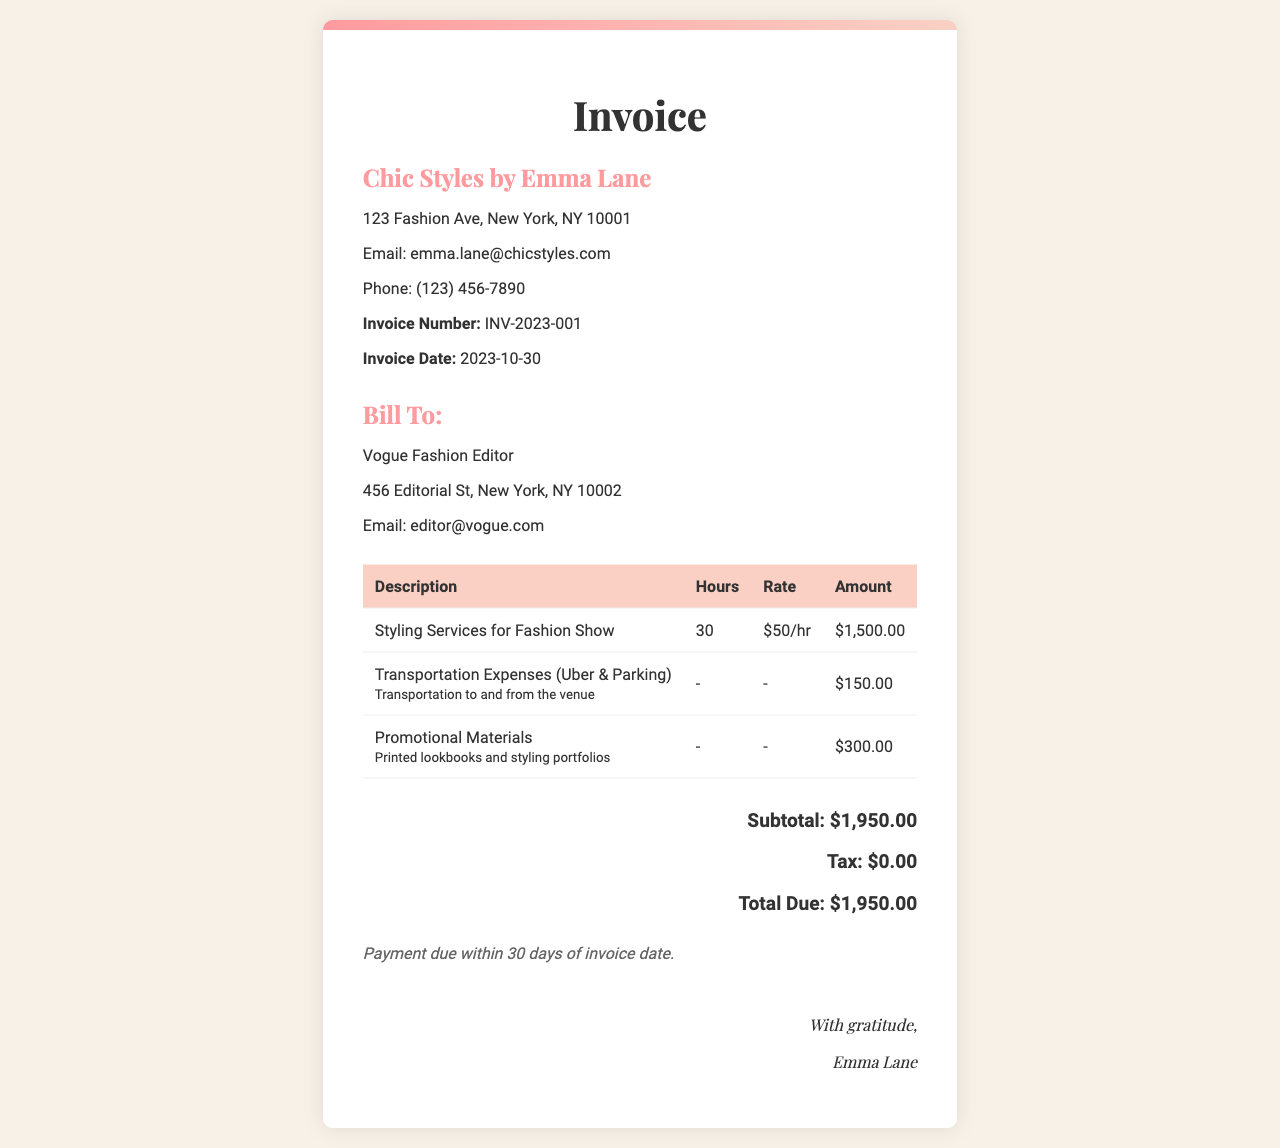What is the invoice number? The invoice number is stated in the header section of the document.
Answer: INV-2023-001 Who is billed in this invoice? The billing section specifies the recipient of the invoice.
Answer: Vogue Fashion Editor What is the total amount due? The total amount is calculated from the subtotal and tax sections.
Answer: $1,950.00 How many hours were worked for styling services? The hours worked are detailed in the table under the styling services description.
Answer: 30 What is the rate for styling services? The rate is specified next to the hours worked in the table.
Answer: $50/hr What is the subtotal for the services provided? The subtotal is calculated from the amounts listed before tax in the document.
Answer: $1,950.00 What are the transportation expenses? The transportation expenses are listed separately in the expenses section of the table.
Answer: $150.00 What is the payment term? The payment terms are stated at the bottom of the invoice, outlining when payment is due.
Answer: Payment due within 30 days of invoice date What is included in the promotional materials expense? The promotional materials description provides details about what they encompass.
Answer: Printed lookbooks and styling portfolios 